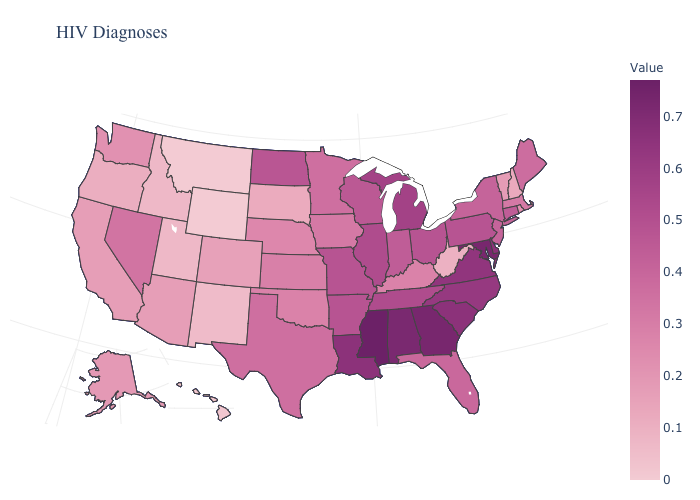Does Mississippi have the highest value in the USA?
Be succinct. Yes. Does the map have missing data?
Give a very brief answer. No. Which states have the lowest value in the West?
Quick response, please. Montana, Wyoming. Does the map have missing data?
Write a very short answer. No. Does New York have the lowest value in the Northeast?
Write a very short answer. No. Does the map have missing data?
Concise answer only. No. Does Oregon have a higher value than Texas?
Write a very short answer. No. Among the states that border Oklahoma , which have the highest value?
Concise answer only. Arkansas, Missouri. Among the states that border Delaware , which have the lowest value?
Keep it brief. New Jersey. 